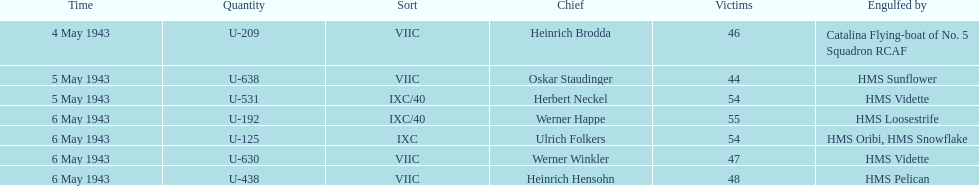Which date had at least 55 casualties? 6 May 1943. 